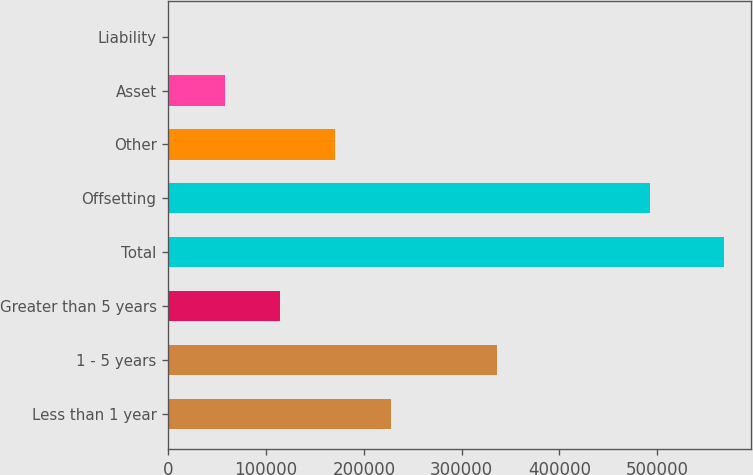Convert chart to OTSL. <chart><loc_0><loc_0><loc_500><loc_500><bar_chart><fcel>Less than 1 year<fcel>1 - 5 years<fcel>Greater than 5 years<fcel>Total<fcel>Offsetting<fcel>Other<fcel>Asset<fcel>Liability<nl><fcel>227641<fcel>335872<fcel>114268<fcel>567758<fcel>492325<fcel>170955<fcel>57582.2<fcel>896<nl></chart> 